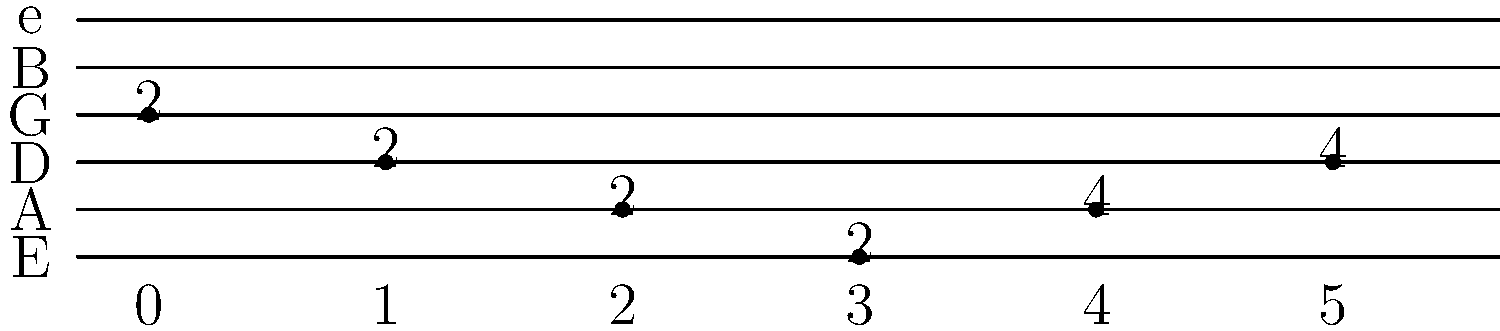Identify the country music riff shown in the guitar tablature above. Which famous country song does this riff belong to? To identify this riff, let's break down the tablature and analyze its components:

1. The tablature shows a sequence of six notes played on different strings and frets.
2. The sequence starts on the G string (3rd string) at the 2nd fret.
3. It then moves to the D string (4th string) at the 2nd fret.
4. The next note is on the A string (5th string) at the 2nd fret.
5. Then it goes to the low E string (6th string) at the 2nd fret.
6. The riff ends with two notes on the A string (5th string) at the 4th fret.

This specific pattern of notes creates a distinctive descending and ascending melody that is instantly recognizable to country music fans. The riff is played at the beginning and throughout the song "Sweet Home Alabama" by Lynyrd Skynyrd.

Although Lynyrd Skynyrd is often associated with Southern rock, "Sweet Home Alabama" has become a staple in country music and is frequently covered by country artists. Its iconic guitar riff is one of the most recognizable in both rock and country music.
Answer: "Sweet Home Alabama" by Lynyrd Skynyrd 